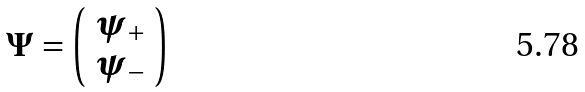Convert formula to latex. <formula><loc_0><loc_0><loc_500><loc_500>\Psi = \left ( \begin{array} { c } \psi _ { + } \\ \psi _ { - } \end{array} \right )</formula> 